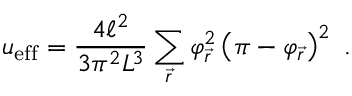Convert formula to latex. <formula><loc_0><loc_0><loc_500><loc_500>u _ { e f f } = \frac { 4 \ell ^ { 2 } } { 3 \pi ^ { 2 } L ^ { 3 } } \sum _ { \vec { r } } \varphi _ { \vec { r } } ^ { 2 } \left ( \pi - \varphi _ { \vec { r } } \right ) ^ { 2 } \ .</formula> 